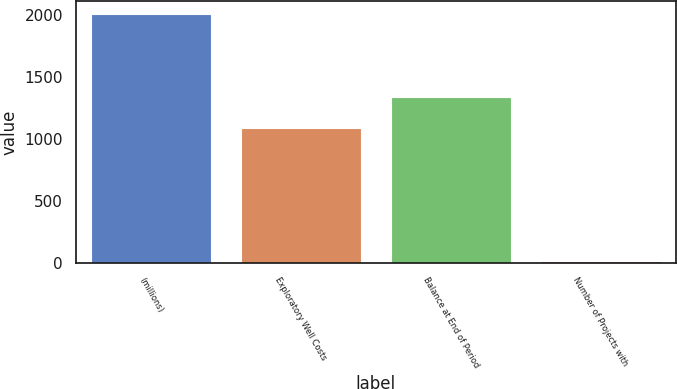Convert chart. <chart><loc_0><loc_0><loc_500><loc_500><bar_chart><fcel>(millions)<fcel>Exploratory Well Costs<fcel>Balance at End of Period<fcel>Number of Projects with<nl><fcel>2014<fcel>1090<fcel>1337<fcel>13<nl></chart> 